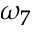Convert formula to latex. <formula><loc_0><loc_0><loc_500><loc_500>\omega _ { 7 }</formula> 